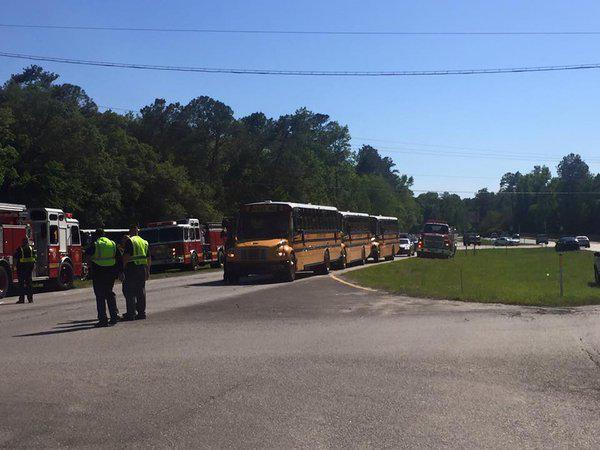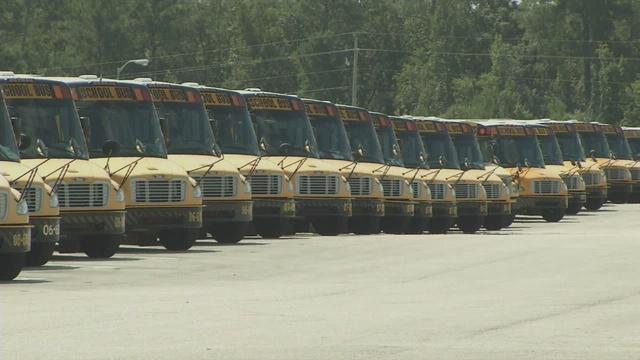The first image is the image on the left, the second image is the image on the right. Assess this claim about the two images: "Exactly one image contains both school buses and fire trucks.". Correct or not? Answer yes or no. Yes. The first image is the image on the left, the second image is the image on the right. For the images shown, is this caption "In at least one image there is one parked yellow bus near one police  vehicle." true? Answer yes or no. No. 